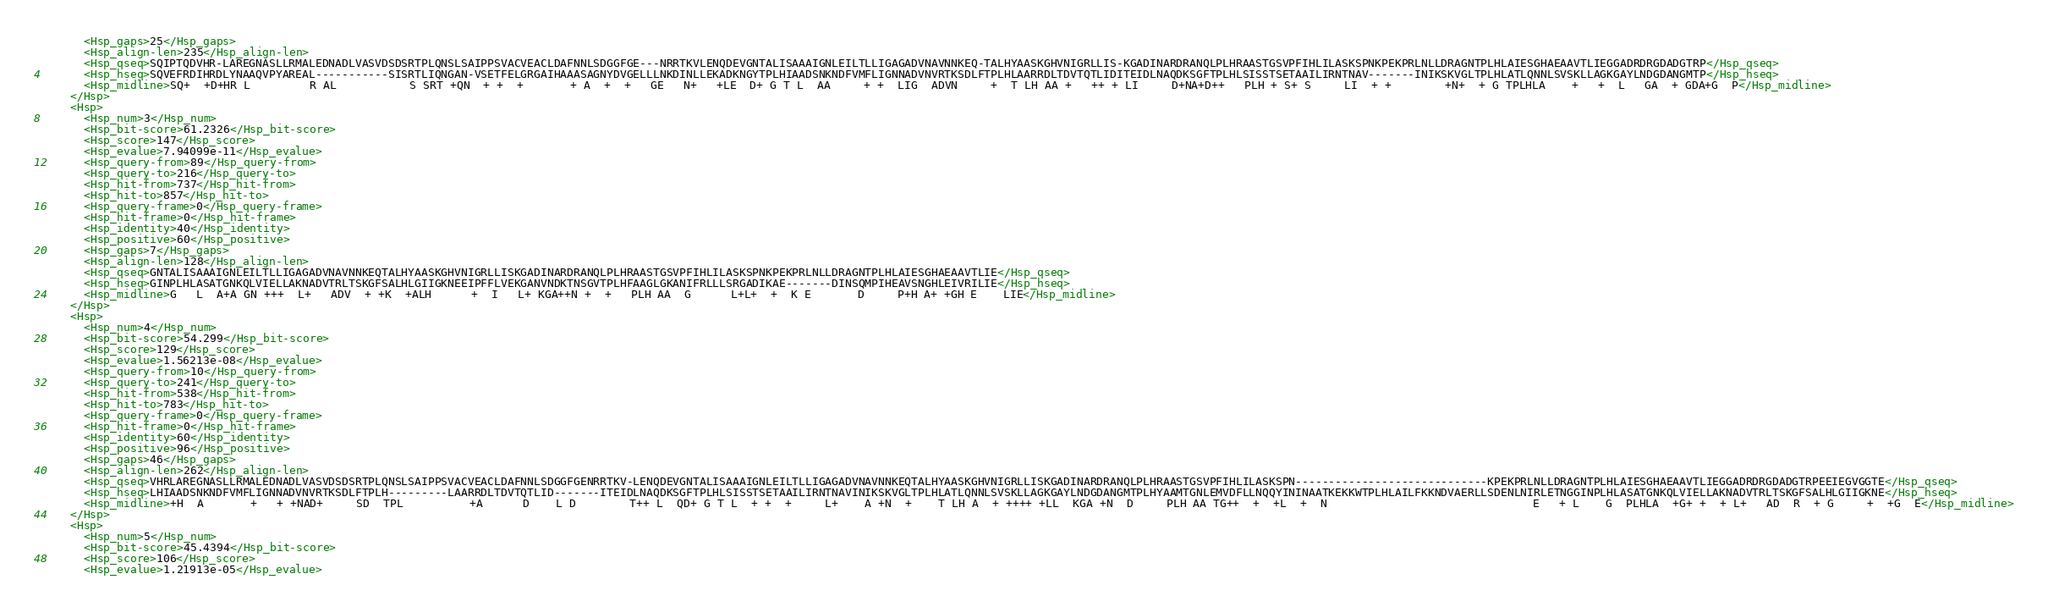Convert code to text. <code><loc_0><loc_0><loc_500><loc_500><_XML_>      <Hsp_gaps>25</Hsp_gaps>
      <Hsp_align-len>235</Hsp_align-len>
      <Hsp_qseq>SQIPTQDVHR-LAREGNASLLRMALEDNADLVASVDSDSRTPLQNSLSAIPPSVACVEACLDAFNNLSDGGFGE---NRRTKVLENQDEVGNTALISAAAIGNLEILTLLIGAGADVNAVNNKEQ-TALHYAASKGHVNIGRLLIS-KGADINARDRANQLPLHRAASTGSVPFIHLILASKSPNKPEKPRLNLLDRAGNTPLHLAIESGHAEAAVTLIEGGADRDRGDADGTRP</Hsp_qseq>
      <Hsp_hseq>SQVEFRDIHRDLYNAAQVPYAREAL-----------SISRTLIQNGAN-VSETFELGRGAIHAAASAGNYDVGELLLNKDINLLEKADKNGYTPLHIAADSNKNDFVMFLIGNNADVNVRTKSDLFTPLHLAARRDLTDVTQTLIDITEIDLNAQDKSGFTPLHLSISSTSETAAILIRNTNAV-------INIKSKVGLTPLHLATLQNNLSVSKLLAGKGAYLNDGDANGMTP</Hsp_hseq>
      <Hsp_midline>SQ+  +D+HR L         R AL           S SRT +QN  + +  +       + A  +  +   GE   N+   +LE  D+ G T L  AA     + +  LIG  ADVN     +  T LH AA +   ++ + LI     D+NA+D++   PLH + S+ S     LI  + +        +N+  + G TPLHLA    +   +  L   GA  + GDA+G  P</Hsp_midline>
    </Hsp>
    <Hsp>
      <Hsp_num>3</Hsp_num>
      <Hsp_bit-score>61.2326</Hsp_bit-score>
      <Hsp_score>147</Hsp_score>
      <Hsp_evalue>7.94099e-11</Hsp_evalue>
      <Hsp_query-from>89</Hsp_query-from>
      <Hsp_query-to>216</Hsp_query-to>
      <Hsp_hit-from>737</Hsp_hit-from>
      <Hsp_hit-to>857</Hsp_hit-to>
      <Hsp_query-frame>0</Hsp_query-frame>
      <Hsp_hit-frame>0</Hsp_hit-frame>
      <Hsp_identity>40</Hsp_identity>
      <Hsp_positive>60</Hsp_positive>
      <Hsp_gaps>7</Hsp_gaps>
      <Hsp_align-len>128</Hsp_align-len>
      <Hsp_qseq>GNTALISAAAIGNLEILTLLIGAGADVNAVNNKEQTALHYAASKGHVNIGRLLISKGADINARDRANQLPLHRAASTGSVPFIHLILASKSPNKPEKPRLNLLDRAGNTPLHLAIESGHAEAAVTLIE</Hsp_qseq>
      <Hsp_hseq>GINPLHLASATGNKQLVIELLAKNADVTRLTSKGFSALHLGIIGKNEEIPFFLVEKGANVNDKTNSGVTPLHFAAGLGKANIFRLLLSRGADIKAE-------DINSQMPIHEAVSNGHLEIVRILIE</Hsp_hseq>
      <Hsp_midline>G   L  A+A GN +++  L+   ADV  + +K  +ALH      +  I   L+ KGA++N +  +   PLH AA  G      L+L+  +  K E       D     P+H A+ +GH E    LIE</Hsp_midline>
    </Hsp>
    <Hsp>
      <Hsp_num>4</Hsp_num>
      <Hsp_bit-score>54.299</Hsp_bit-score>
      <Hsp_score>129</Hsp_score>
      <Hsp_evalue>1.56213e-08</Hsp_evalue>
      <Hsp_query-from>10</Hsp_query-from>
      <Hsp_query-to>241</Hsp_query-to>
      <Hsp_hit-from>538</Hsp_hit-from>
      <Hsp_hit-to>783</Hsp_hit-to>
      <Hsp_query-frame>0</Hsp_query-frame>
      <Hsp_hit-frame>0</Hsp_hit-frame>
      <Hsp_identity>60</Hsp_identity>
      <Hsp_positive>96</Hsp_positive>
      <Hsp_gaps>46</Hsp_gaps>
      <Hsp_align-len>262</Hsp_align-len>
      <Hsp_qseq>VHRLAREGNASLLRMALEDNADLVASVDSDSRTPLQNSLSAIPPSVACVEACLDAFNNLSDGGFGENRRTKV-LENQDEVGNTALISAAAIGNLEILTLLIGAGADVNAVNNKEQTALHYAASKGHVNIGRLLISKGADINARDRANQLPLHRAASTGSVPFIHLILASKSPN-----------------------------KPEKPRLNLLDRAGNTPLHLAIESGHAEAAVTLIEGGADRDRGDADGTRPEEIEGVGGTE</Hsp_qseq>
      <Hsp_hseq>LHIAADSNKNDFVMFLIGNNADVNVRTKSDLFTPLH---------LAARRDLTDVTQTLID-------ITEIDLNAQDKSGFTPLHLSISSTSETAAILIRNTNAVINIKSKVGLTPLHLATLQNNLSVSKLLAGKGAYLNDGDANGMTPLHYAAMTGNLEMVDFLLNQQYININAATKEKKWTPLHLAILFKKNDVAERLLSDENLNIRLETNGGINPLHLASATGNKQLVIELLAKNADVTRLTSKGFSALHLGIIGKNE</Hsp_hseq>
      <Hsp_midline>+H  A       +   + +NAD+     SD  TPL          +A      D    L D        T++ L  QD+ G T L  + +  +     L+    A +N  +    T LH A  + ++++ +LL  KGA +N  D     PLH AA TG++  +  +L  +  N                               E   + L    G  PLHLA  +G+ +  + L+   AD  R  + G     +  +G  E</Hsp_midline>
    </Hsp>
    <Hsp>
      <Hsp_num>5</Hsp_num>
      <Hsp_bit-score>45.4394</Hsp_bit-score>
      <Hsp_score>106</Hsp_score>
      <Hsp_evalue>1.21913e-05</Hsp_evalue></code> 